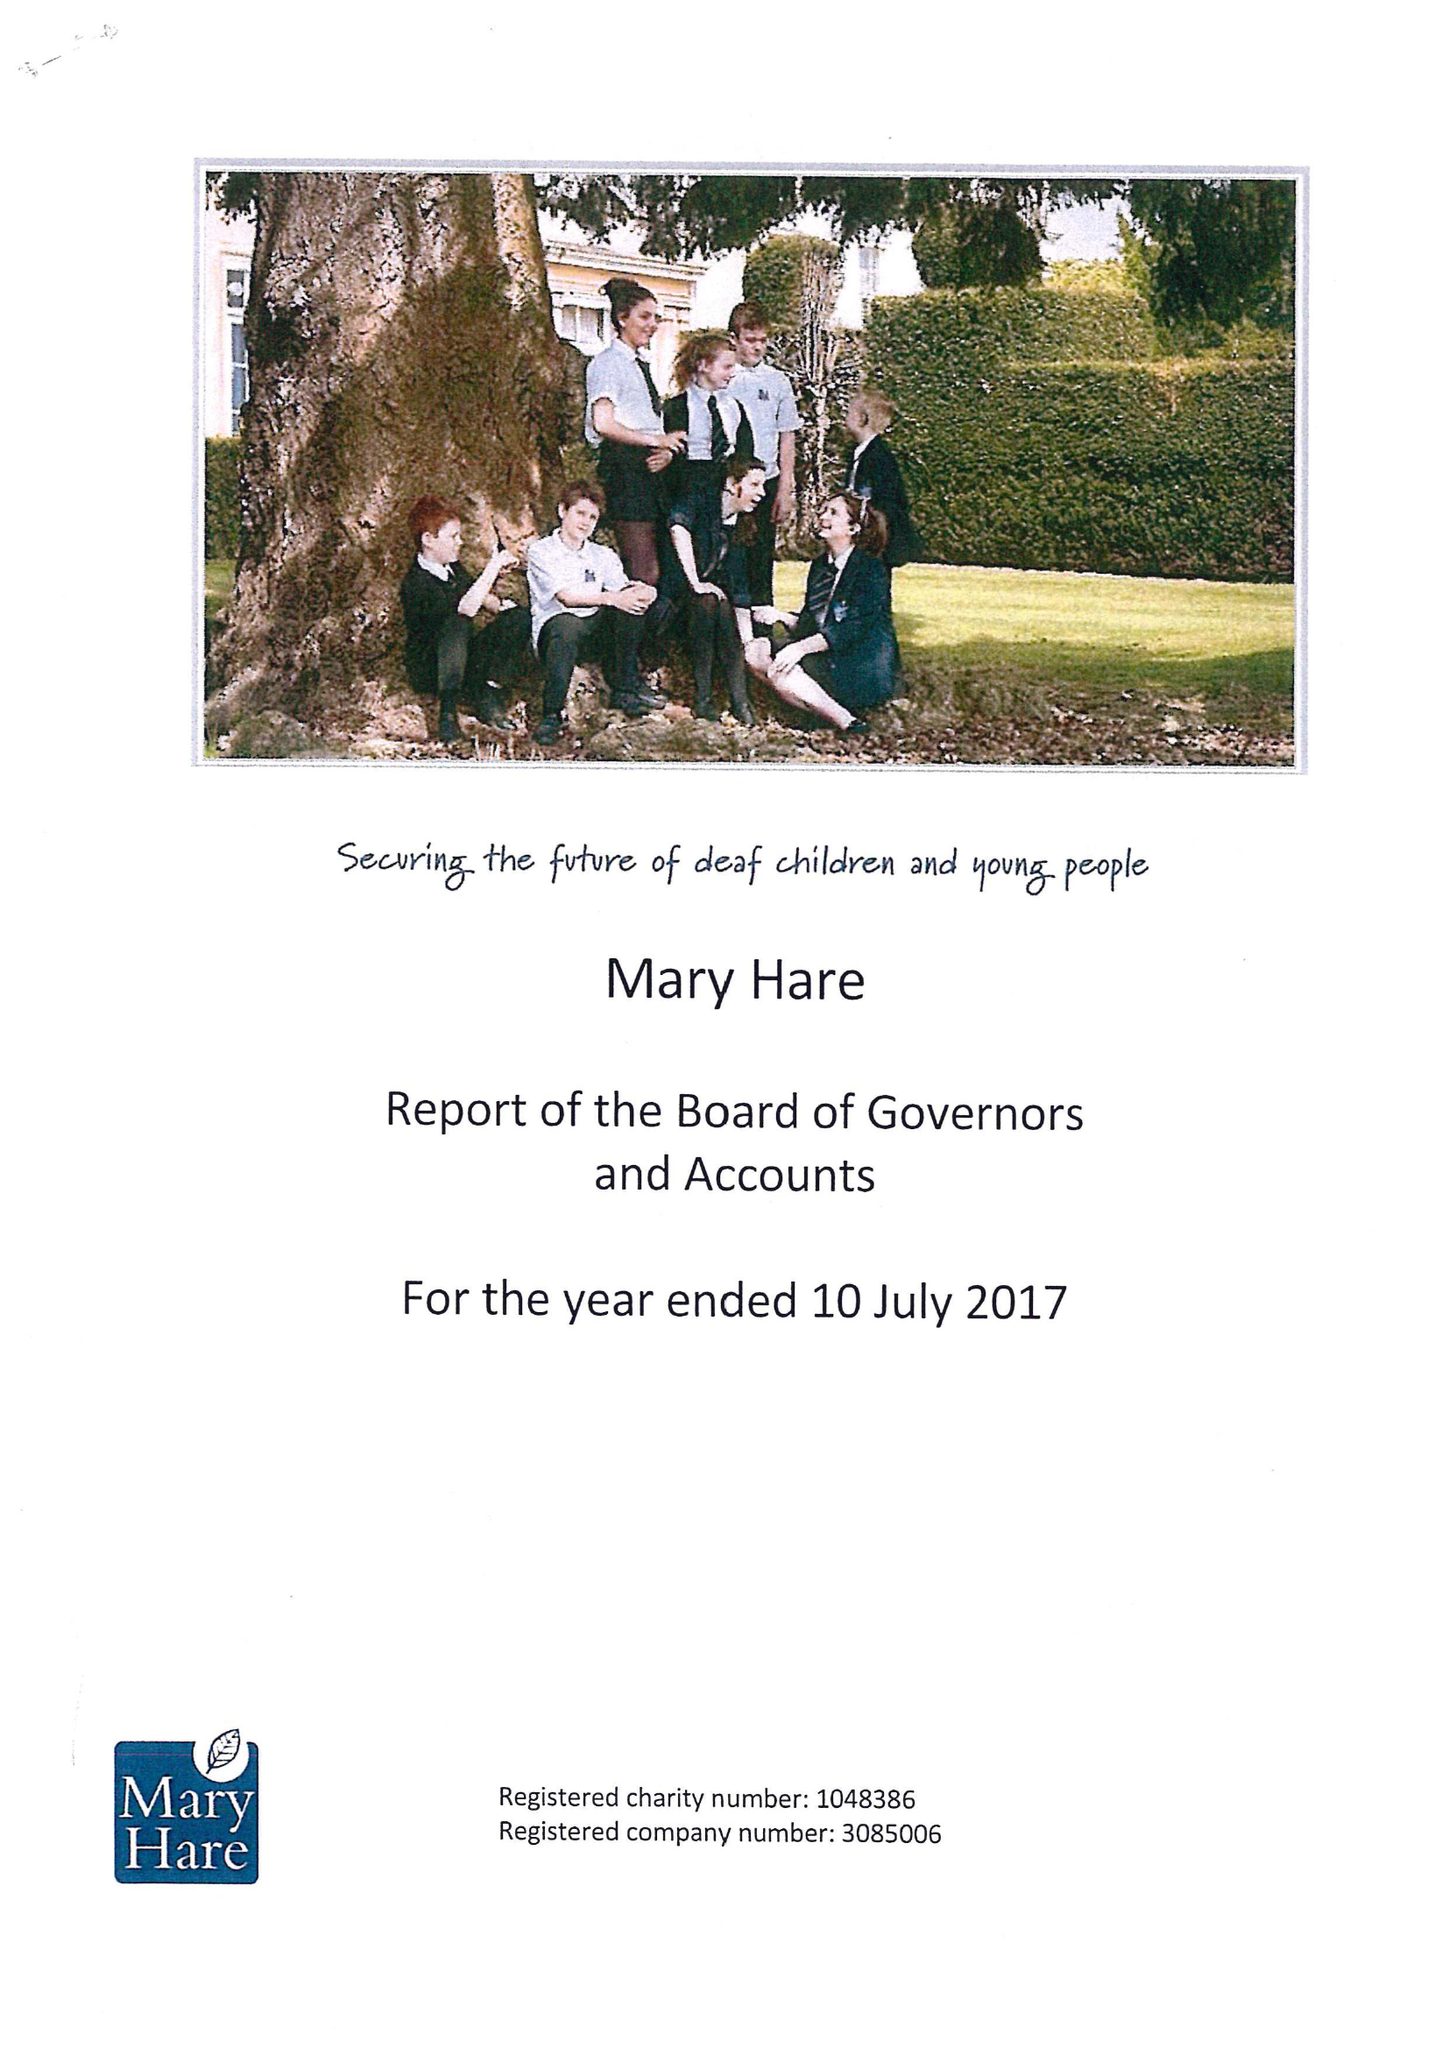What is the value for the report_date?
Answer the question using a single word or phrase. 2017-07-10 